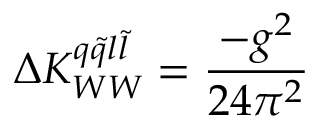Convert formula to latex. <formula><loc_0><loc_0><loc_500><loc_500>\Delta K _ { W W } ^ { q \tilde { q } l \tilde { l } } = \frac { - g ^ { 2 } } { 2 4 \pi ^ { 2 } }</formula> 